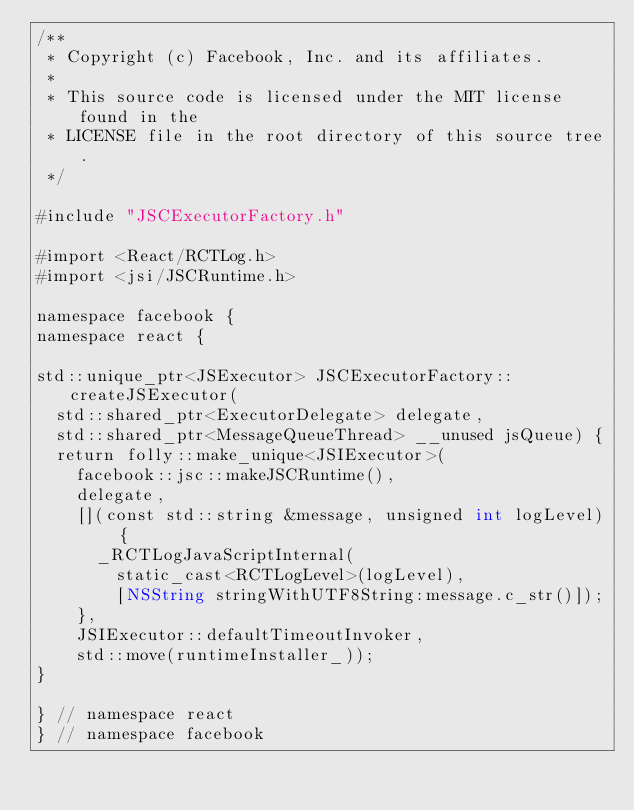Convert code to text. <code><loc_0><loc_0><loc_500><loc_500><_ObjectiveC_>/**
 * Copyright (c) Facebook, Inc. and its affiliates.
 *
 * This source code is licensed under the MIT license found in the
 * LICENSE file in the root directory of this source tree.
 */

#include "JSCExecutorFactory.h"

#import <React/RCTLog.h>
#import <jsi/JSCRuntime.h>

namespace facebook {
namespace react {

std::unique_ptr<JSExecutor> JSCExecutorFactory::createJSExecutor(
  std::shared_ptr<ExecutorDelegate> delegate,
  std::shared_ptr<MessageQueueThread> __unused jsQueue) {
  return folly::make_unique<JSIExecutor>(
    facebook::jsc::makeJSCRuntime(),
    delegate,
    [](const std::string &message, unsigned int logLevel) {
      _RCTLogJavaScriptInternal(
        static_cast<RCTLogLevel>(logLevel),
        [NSString stringWithUTF8String:message.c_str()]);
    },
    JSIExecutor::defaultTimeoutInvoker,
    std::move(runtimeInstaller_));
}

} // namespace react
} // namespace facebook
</code> 